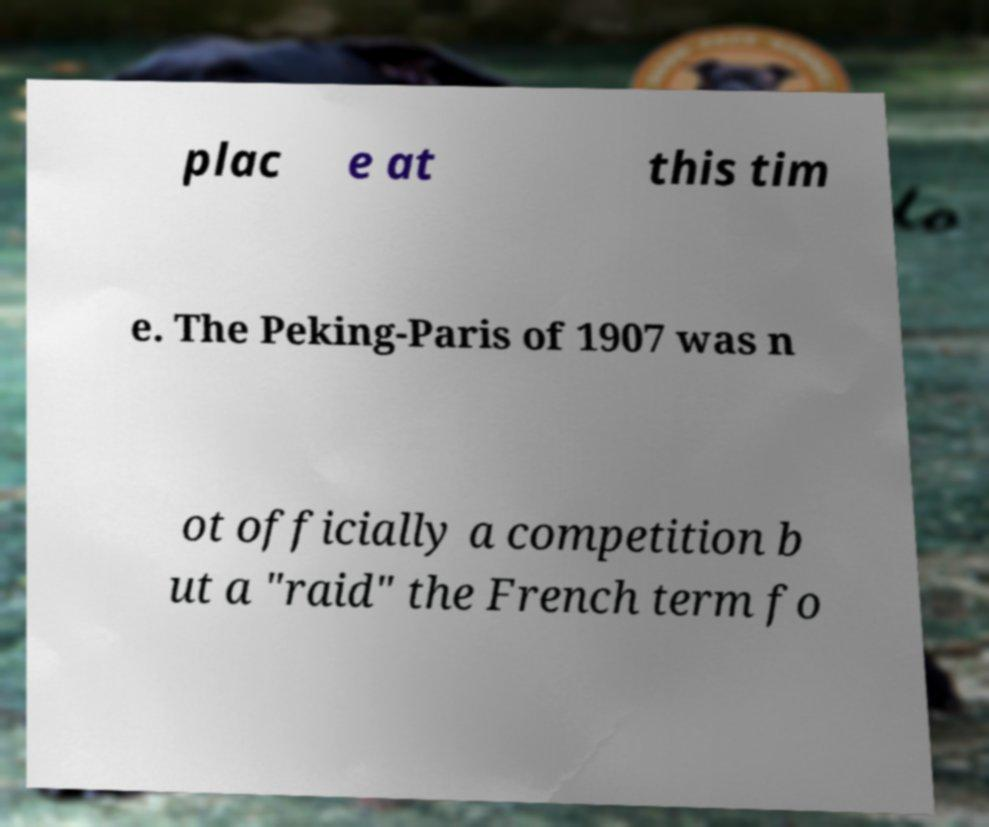Could you extract and type out the text from this image? plac e at this tim e. The Peking-Paris of 1907 was n ot officially a competition b ut a "raid" the French term fo 